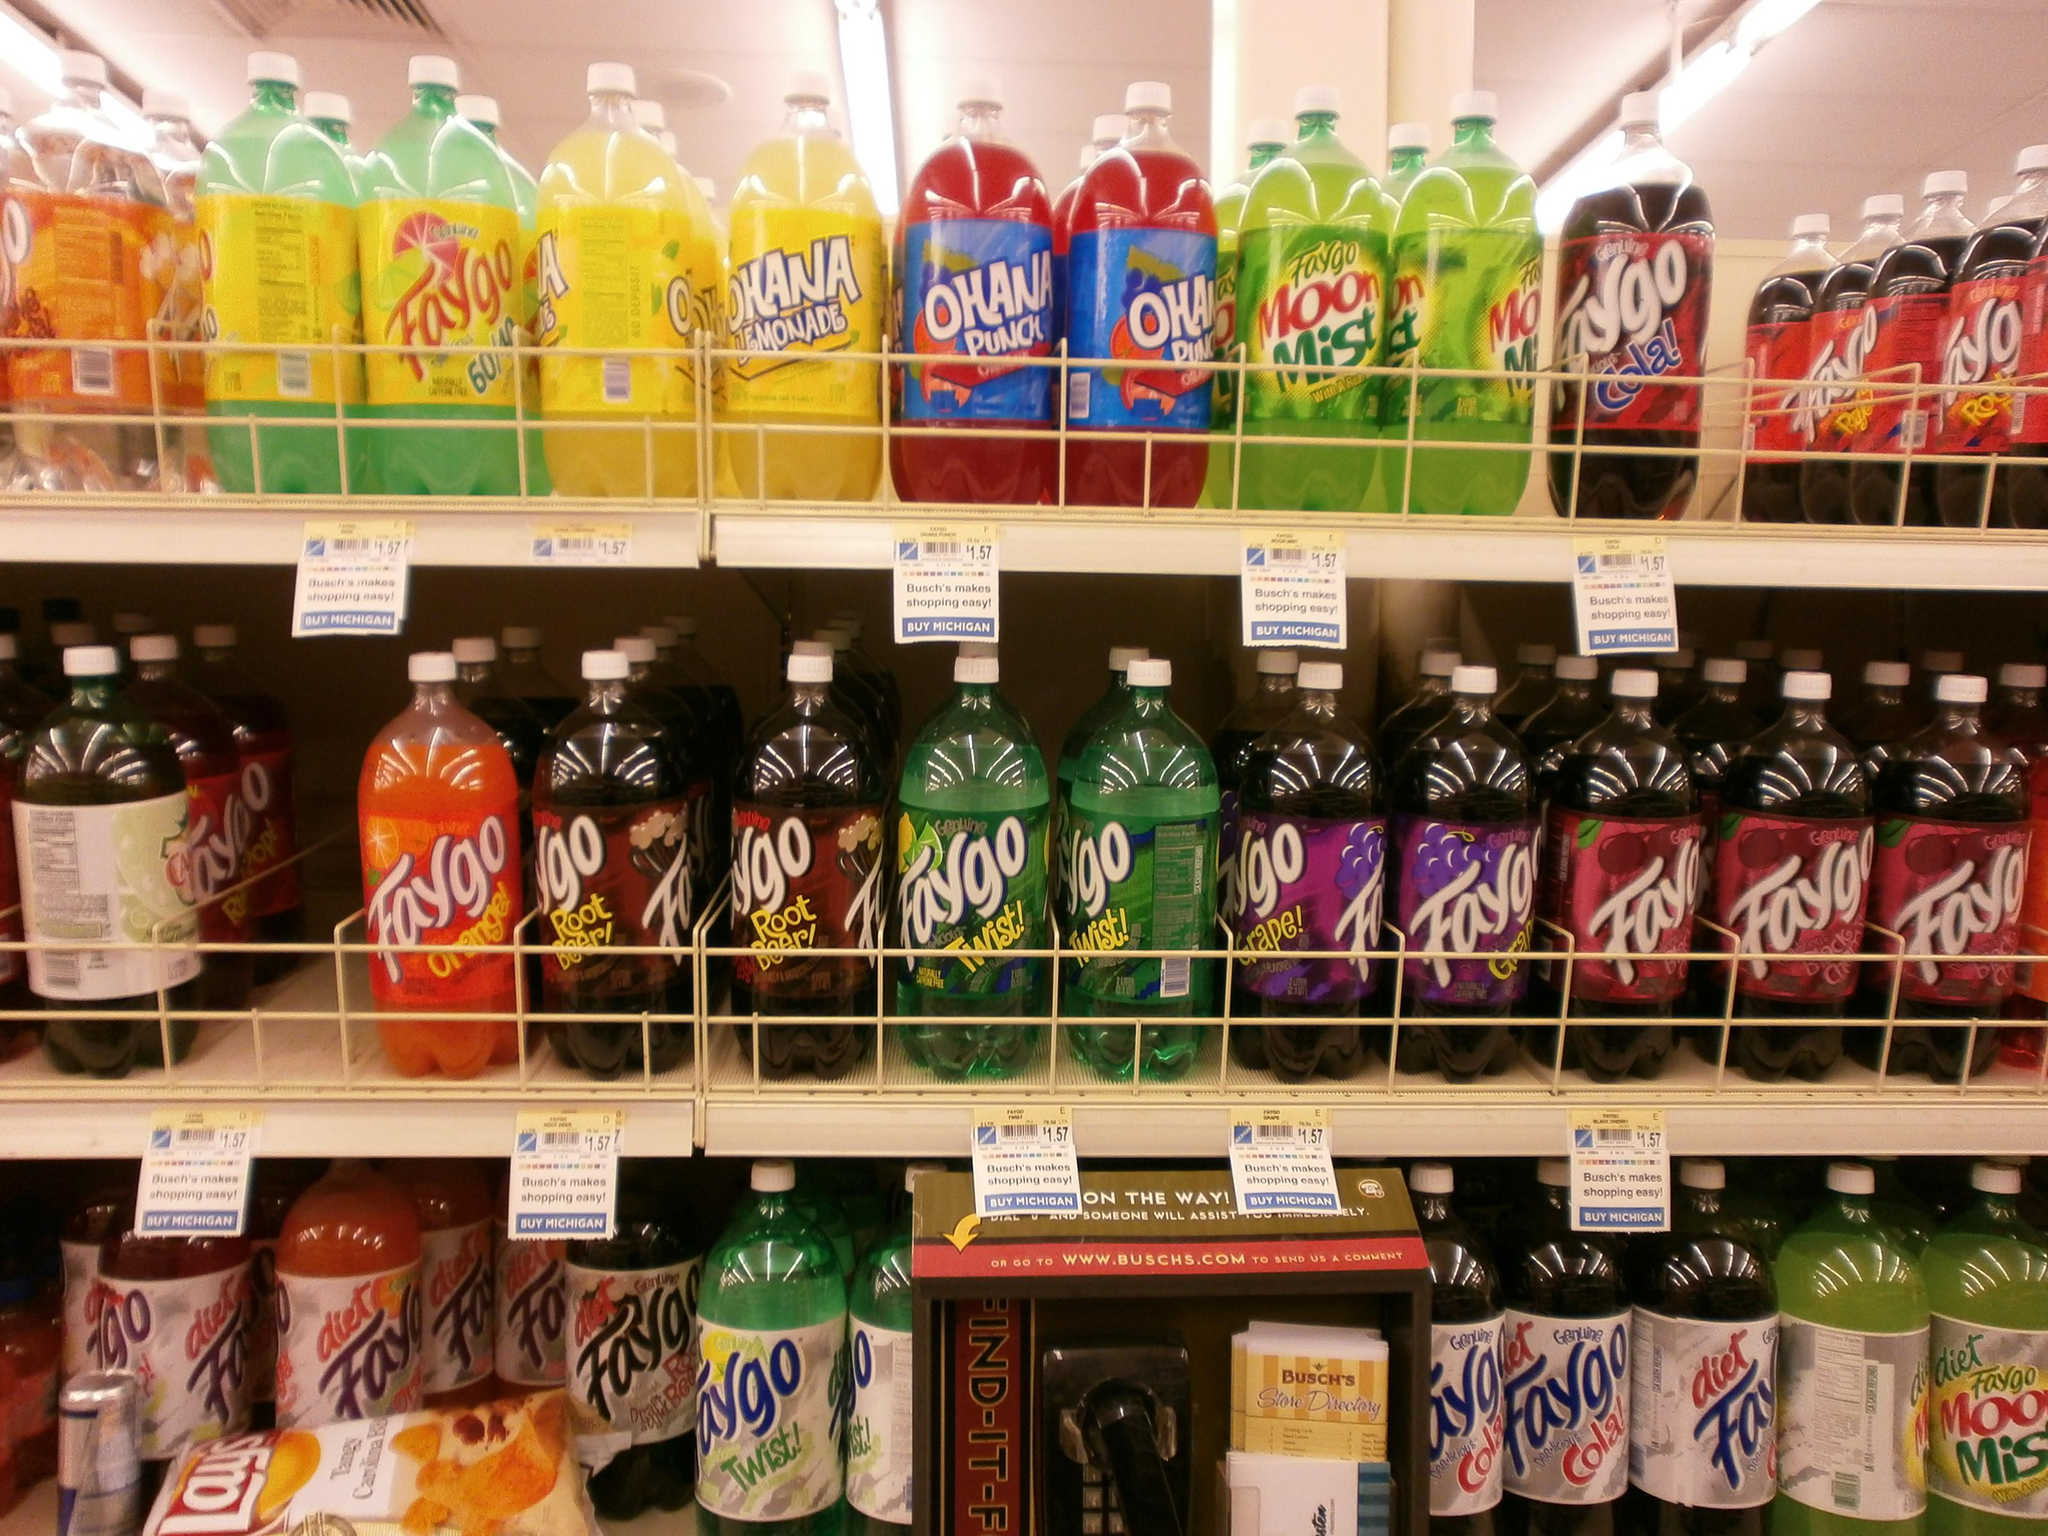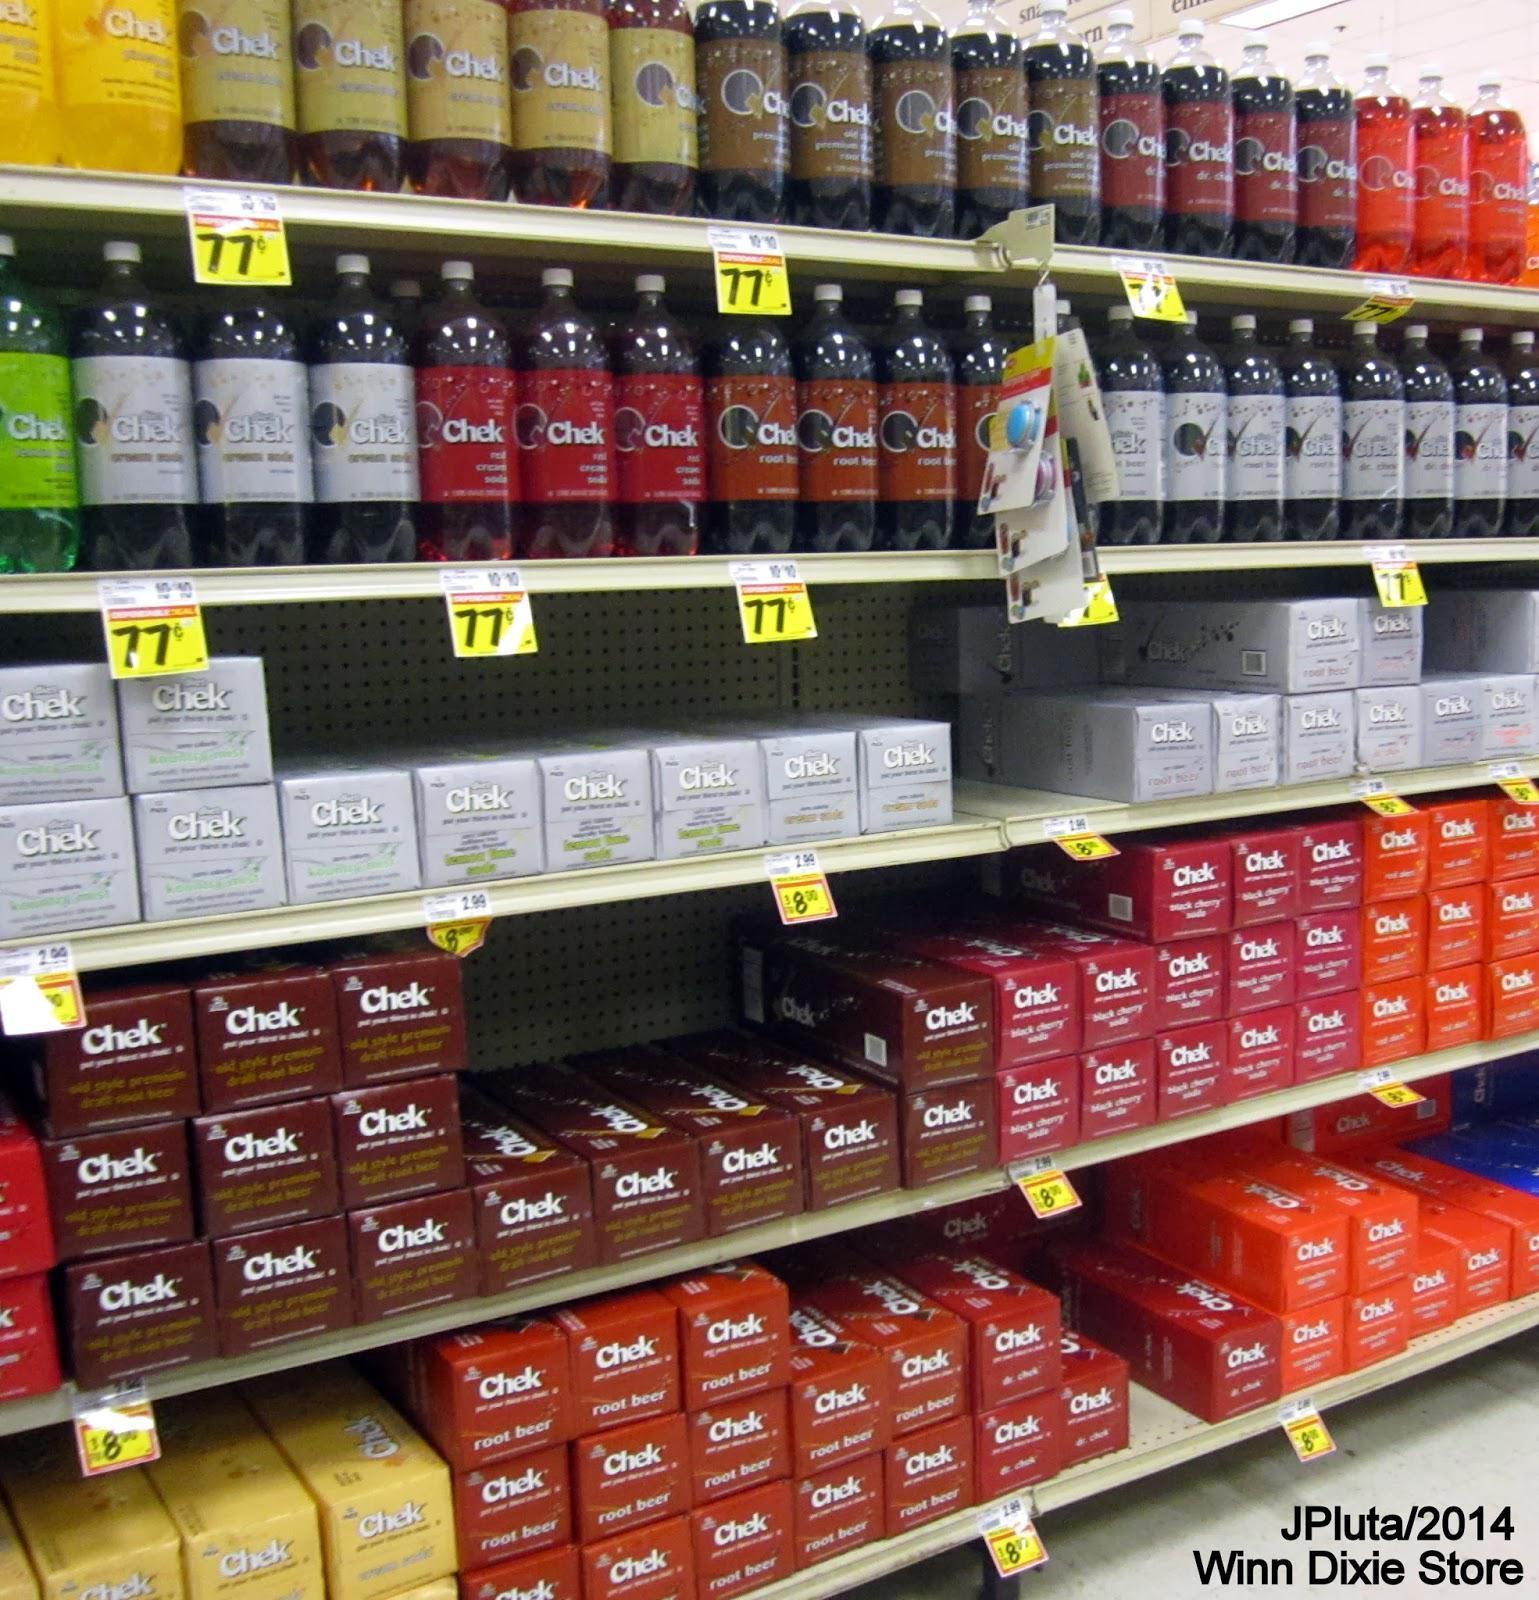The first image is the image on the left, the second image is the image on the right. Examine the images to the left and right. Is the description "One image features sodas on shelves with at least one white card on a shelf edge, and the other image features sodas on shelves with yellow cards on the edges." accurate? Answer yes or no. Yes. 